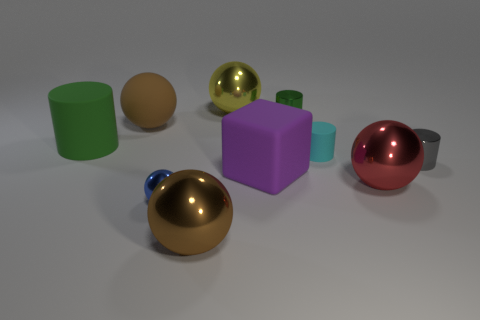Are there fewer cylinders that are left of the big yellow thing than tiny green shiny cylinders?
Provide a short and direct response. No. What number of tiny cylinders are the same color as the large rubber cylinder?
Ensure brevity in your answer.  1. There is a big sphere that is to the left of the big purple object and in front of the rubber cube; what material is it made of?
Keep it short and to the point. Metal. There is a large shiny object that is to the left of the yellow object; is its color the same as the big sphere to the left of the blue ball?
Your answer should be compact. Yes. What number of gray objects are either tiny metallic cylinders or big matte cubes?
Your answer should be very brief. 1. Are there fewer big red metal objects behind the small green shiny thing than large shiny balls that are behind the purple object?
Provide a short and direct response. Yes. Is there a yellow ball of the same size as the cube?
Provide a short and direct response. Yes. Does the green cylinder that is on the right side of the brown rubber ball have the same size as the cyan matte cylinder?
Make the answer very short. Yes. Is the number of tiny balls greater than the number of small metallic things?
Offer a very short reply. No. Are there any tiny objects of the same shape as the large green thing?
Provide a short and direct response. Yes. 